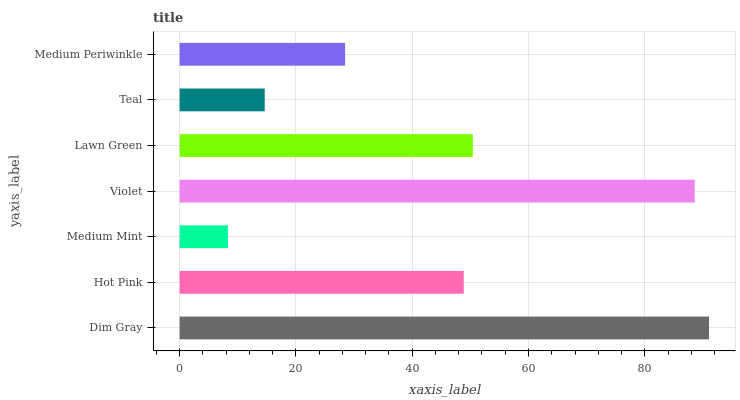Is Medium Mint the minimum?
Answer yes or no. Yes. Is Dim Gray the maximum?
Answer yes or no. Yes. Is Hot Pink the minimum?
Answer yes or no. No. Is Hot Pink the maximum?
Answer yes or no. No. Is Dim Gray greater than Hot Pink?
Answer yes or no. Yes. Is Hot Pink less than Dim Gray?
Answer yes or no. Yes. Is Hot Pink greater than Dim Gray?
Answer yes or no. No. Is Dim Gray less than Hot Pink?
Answer yes or no. No. Is Hot Pink the high median?
Answer yes or no. Yes. Is Hot Pink the low median?
Answer yes or no. Yes. Is Violet the high median?
Answer yes or no. No. Is Teal the low median?
Answer yes or no. No. 